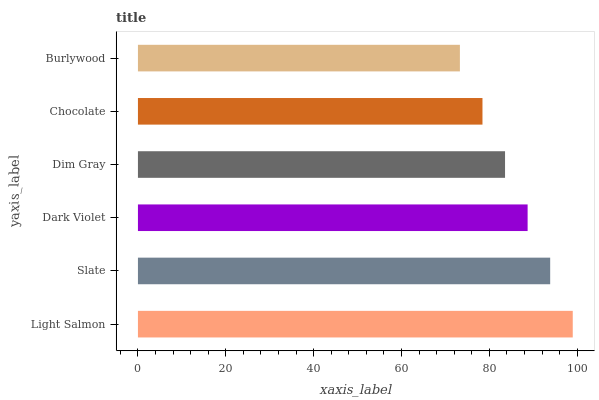Is Burlywood the minimum?
Answer yes or no. Yes. Is Light Salmon the maximum?
Answer yes or no. Yes. Is Slate the minimum?
Answer yes or no. No. Is Slate the maximum?
Answer yes or no. No. Is Light Salmon greater than Slate?
Answer yes or no. Yes. Is Slate less than Light Salmon?
Answer yes or no. Yes. Is Slate greater than Light Salmon?
Answer yes or no. No. Is Light Salmon less than Slate?
Answer yes or no. No. Is Dark Violet the high median?
Answer yes or no. Yes. Is Dim Gray the low median?
Answer yes or no. Yes. Is Chocolate the high median?
Answer yes or no. No. Is Burlywood the low median?
Answer yes or no. No. 